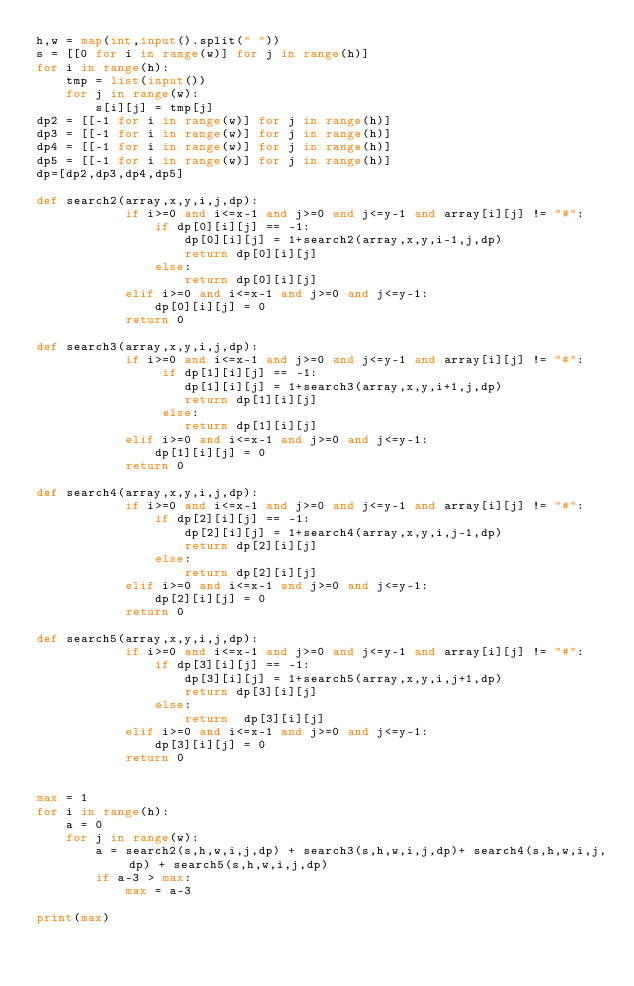Convert code to text. <code><loc_0><loc_0><loc_500><loc_500><_Python_>h,w = map(int,input().split(" "))
s = [[0 for i in range(w)] for j in range(h)]
for i in range(h):
    tmp = list(input())
    for j in range(w):
        s[i][j] = tmp[j]
dp2 = [[-1 for i in range(w)] for j in range(h)]
dp3 = [[-1 for i in range(w)] for j in range(h)]
dp4 = [[-1 for i in range(w)] for j in range(h)]
dp5 = [[-1 for i in range(w)] for j in range(h)]
dp=[dp2,dp3,dp4,dp5]

def search2(array,x,y,i,j,dp):
            if i>=0 and i<=x-1 and j>=0 and j<=y-1 and array[i][j] != "#":
                if dp[0][i][j] == -1:
                    dp[0][i][j] = 1+search2(array,x,y,i-1,j,dp)
                    return dp[0][i][j]
                else:
                    return dp[0][i][j]
            elif i>=0 and i<=x-1 and j>=0 and j<=y-1:
                dp[0][i][j] = 0
            return 0

def search3(array,x,y,i,j,dp):
            if i>=0 and i<=x-1 and j>=0 and j<=y-1 and array[i][j] != "#":
                 if dp[1][i][j] == -1:
                    dp[1][i][j] = 1+search3(array,x,y,i+1,j,dp)
                    return dp[1][i][j]
                 else:
                    return dp[1][i][j]
            elif i>=0 and i<=x-1 and j>=0 and j<=y-1:
                dp[1][i][j] = 0
            return 0

def search4(array,x,y,i,j,dp):
            if i>=0 and i<=x-1 and j>=0 and j<=y-1 and array[i][j] != "#":
                if dp[2][i][j] == -1:
                    dp[2][i][j] = 1+search4(array,x,y,i,j-1,dp)
                    return dp[2][i][j]
                else:
                    return dp[2][i][j]
            elif i>=0 and i<=x-1 and j>=0 and j<=y-1:
                dp[2][i][j] = 0
            return 0

def search5(array,x,y,i,j,dp):
            if i>=0 and i<=x-1 and j>=0 and j<=y-1 and array[i][j] != "#":
                if dp[3][i][j] == -1:
                    dp[3][i][j] = 1+search5(array,x,y,i,j+1,dp)
                    return dp[3][i][j]
                else:
                    return  dp[3][i][j]
            elif i>=0 and i<=x-1 and j>=0 and j<=y-1:
                dp[3][i][j] = 0
            return 0

            
max = 1
for i in range(h):
    a = 0
    for j in range(w):
        a = search2(s,h,w,i,j,dp) + search3(s,h,w,i,j,dp)+ search4(s,h,w,i,j,dp) + search5(s,h,w,i,j,dp)
        if a-3 > max:
            max = a-3

print(max)</code> 